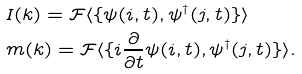<formula> <loc_0><loc_0><loc_500><loc_500>& I ( { k } ) = \mathcal { F } \langle \{ \psi ( { i } , t ) , \psi ^ { \dagger } ( { j } , t ) \} \rangle \\ & m ( { k } ) = \mathcal { F } \langle \{ i \frac { \partial } { \partial t } \psi ( { i } , t ) , \psi ^ { \dagger } ( { j } , t ) \} \rangle .</formula> 